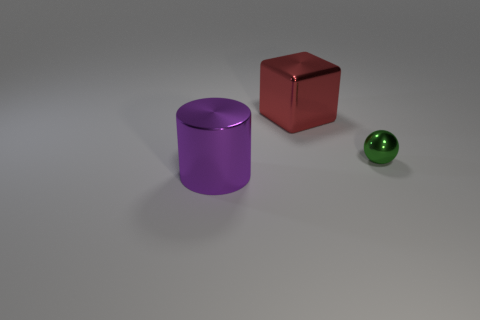Can you guess the materials of the objects based on their appearance? The objects look like they could be computer-generated representations, which are designed to mimic real-life materials. The shiny sphere seems as if it could be made of glass or polished metal, the purple cylinder resembles colored plastic, and the red cube might suggest painted wood. 